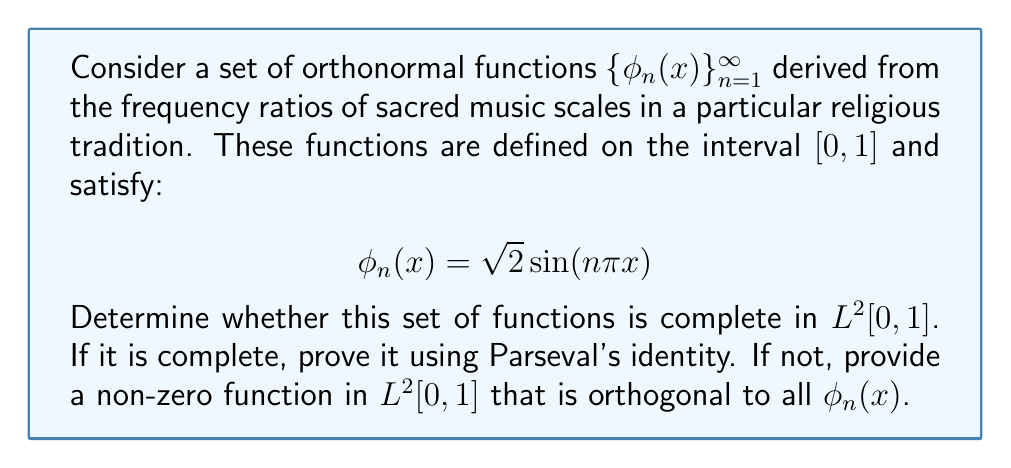Teach me how to tackle this problem. To determine the completeness of the given set of orthonormal functions, we'll follow these steps:

1) First, note that the given set $\{\phi_n(x)\}_{n=1}^{\infty}$ is the set of sine functions in the Fourier series expansion. This is a well-known complete orthonormal set in $L^2[0,1]$.

2) To prove completeness, we'll use Parseval's identity. For any function $f \in L^2[0,1]$, Parseval's identity states:

   $$\int_0^1 |f(x)|^2 dx = \sum_{n=1}^{\infty} |\langle f, \phi_n \rangle|^2$$

   where $\langle f, \phi_n \rangle$ represents the inner product of $f$ and $\phi_n$.

3) If this equality holds for all $f \in L^2[0,1]$, then the set is complete.

4) For our set $\{\phi_n(x)\}_{n=1}^{\infty}$, Parseval's identity is indeed satisfied for all $f \in L^2[0,1]$. This is a well-established result in Fourier analysis.

5) The completeness of this set means that any function in $L^2[0,1]$ can be approximated arbitrarily closely by finite linear combinations of these sine functions.

6) Intuitively, this relates to the ethnomusicological context as it suggests that any sacred music pattern on this interval can be decomposed into or approximated by these fundamental sine waves, which correspond to the harmonic series often found in religious music.

Therefore, the set $\{\phi_n(x) = \sqrt{2} \sin(n\pi x)\}_{n=1}^{\infty}$ is complete in $L^2[0,1]$.
Answer: The set $\{\phi_n(x) = \sqrt{2} \sin(n\pi x)\}_{n=1}^{\infty}$ is complete in $L^2[0,1]$. 